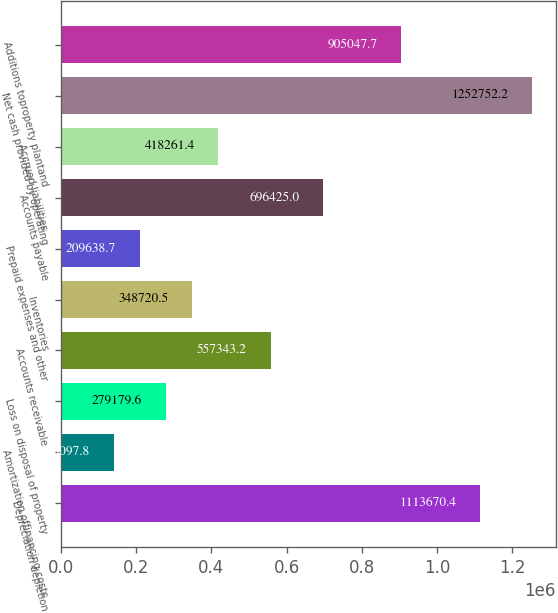Convert chart. <chart><loc_0><loc_0><loc_500><loc_500><bar_chart><fcel>Depreciation depletion<fcel>Amortization offinancing costs<fcel>Loss on disposal of property<fcel>Accounts receivable<fcel>Inventories<fcel>Prepaid expenses and other<fcel>Accounts payable<fcel>Accrued liabilities<fcel>Net cash provided by operating<fcel>Additions toproperty plantand<nl><fcel>1.11367e+06<fcel>140098<fcel>279180<fcel>557343<fcel>348720<fcel>209639<fcel>696425<fcel>418261<fcel>1.25275e+06<fcel>905048<nl></chart> 